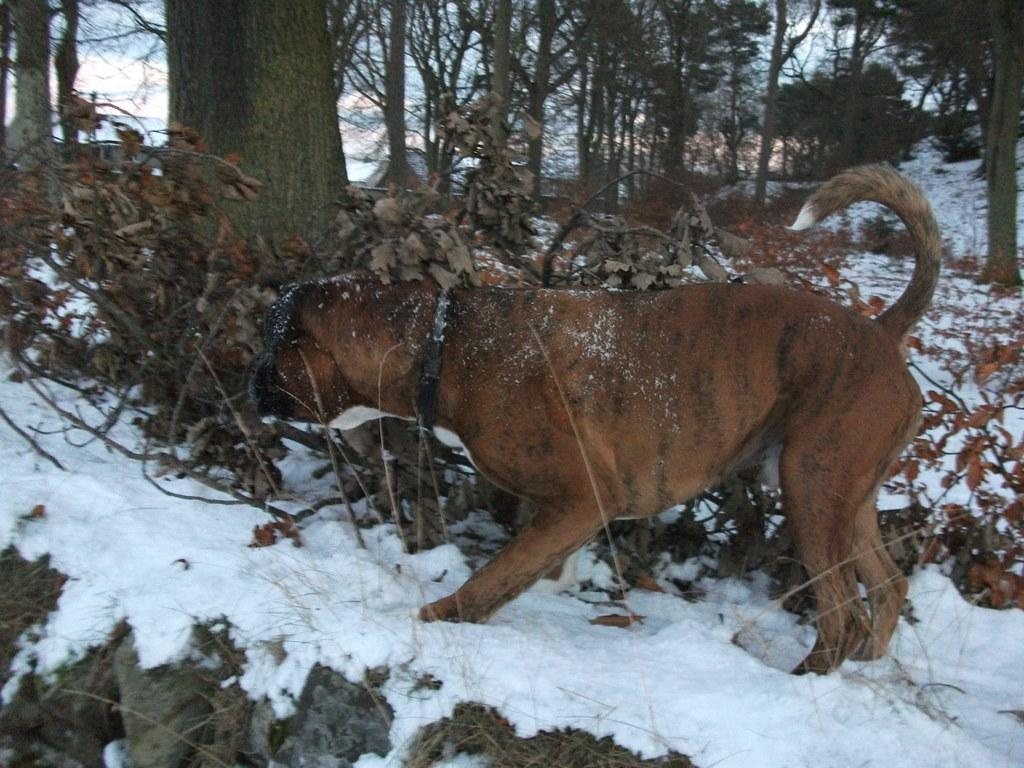What animal is in the image? There is a dog in the image. What is the dog standing on? The dog is standing on the snow. Where is the dog located in the image? The dog is in the center of the image. What can be seen in the background of the image? There are dry leaves and trees in the background of the image. What is the ground covered with? The ground is covered in snow. What type of worm can be seen crawling on the dog's fur in the image? There is no worm present in the image; the dog is standing on snow and there are no worms visible. 